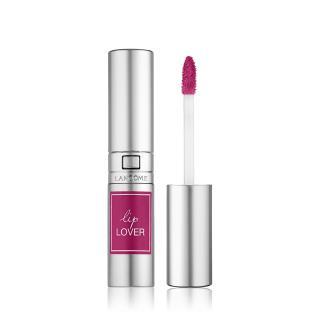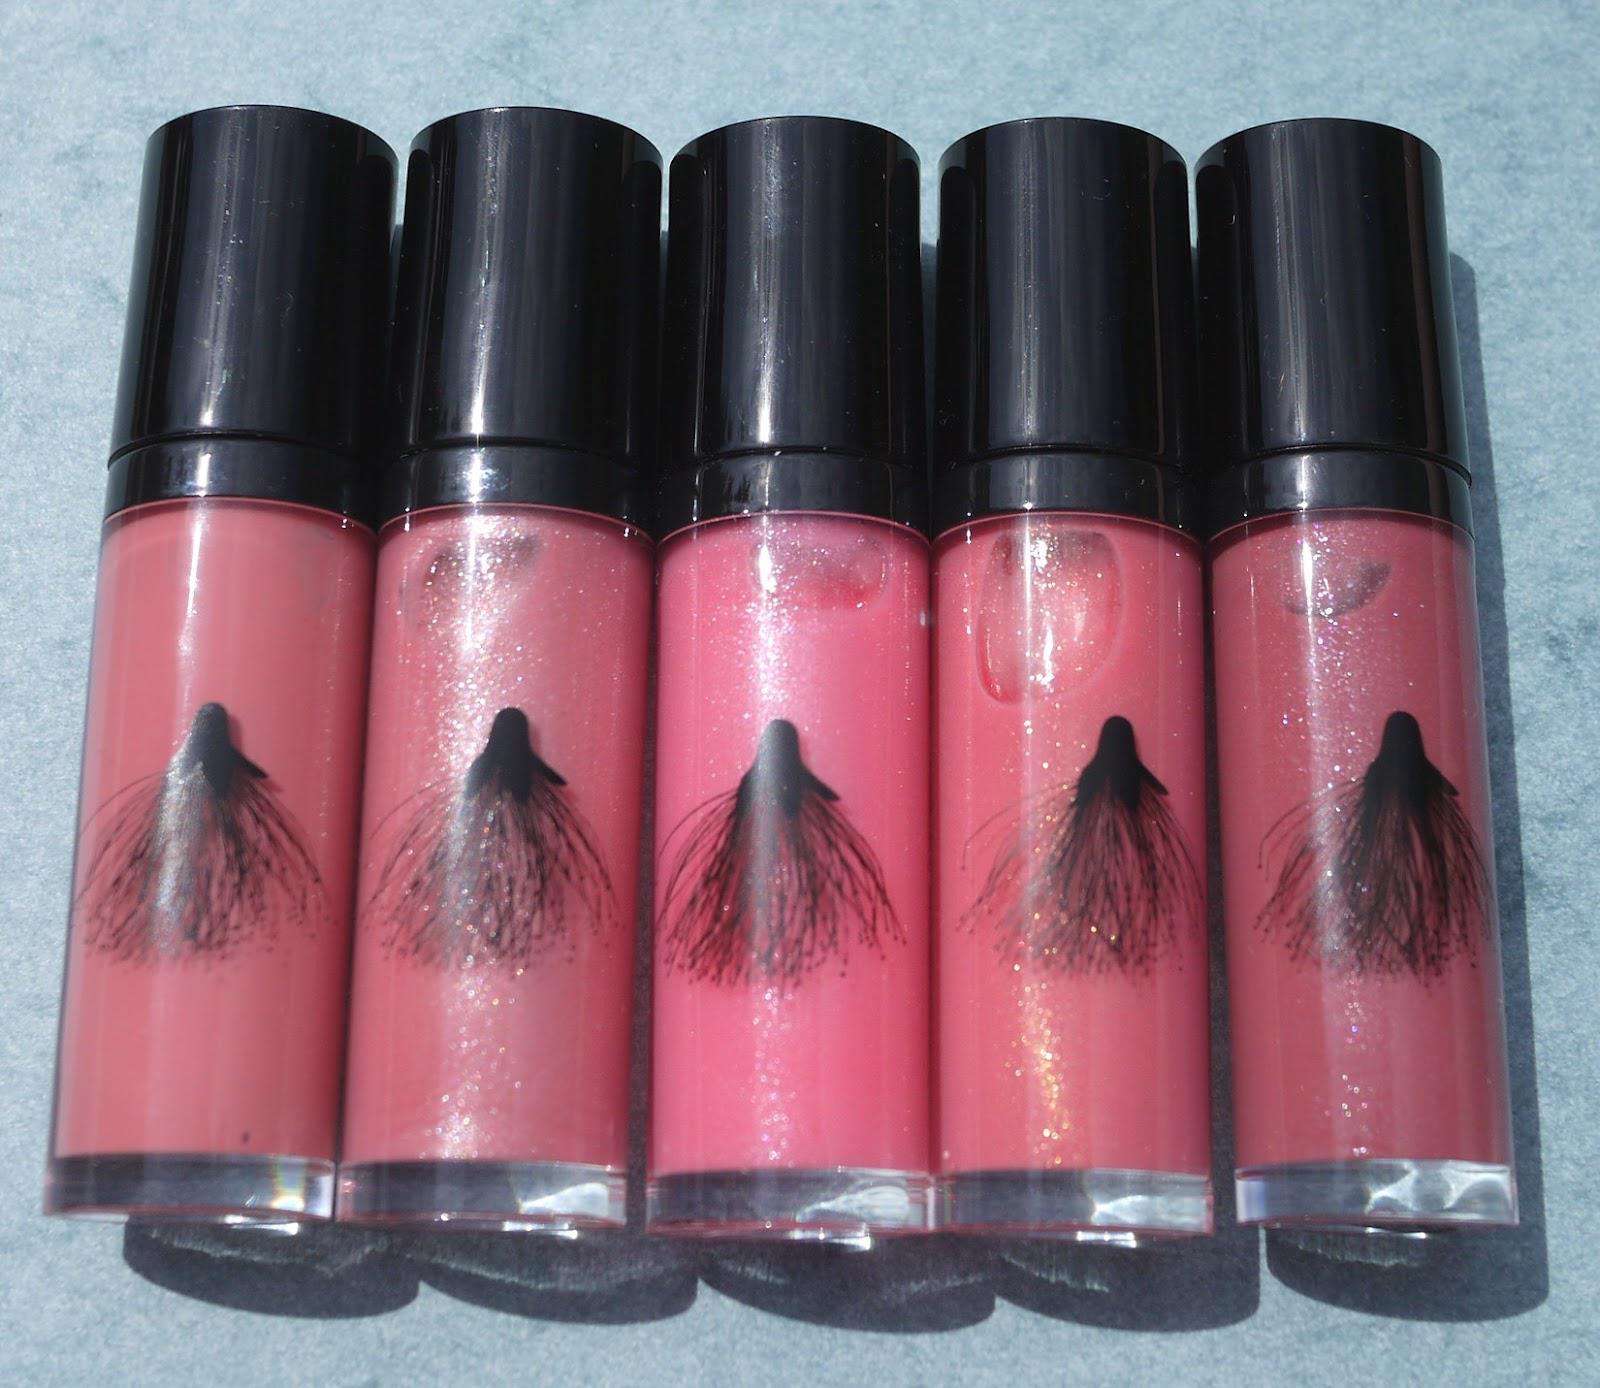The first image is the image on the left, the second image is the image on the right. Given the left and right images, does the statement "The five black caps of the makeup in the image on the right are fully visible." hold true? Answer yes or no. Yes. The first image is the image on the left, the second image is the image on the right. Assess this claim about the two images: "One image shows a lip makeup with its cover off.". Correct or not? Answer yes or no. Yes. 